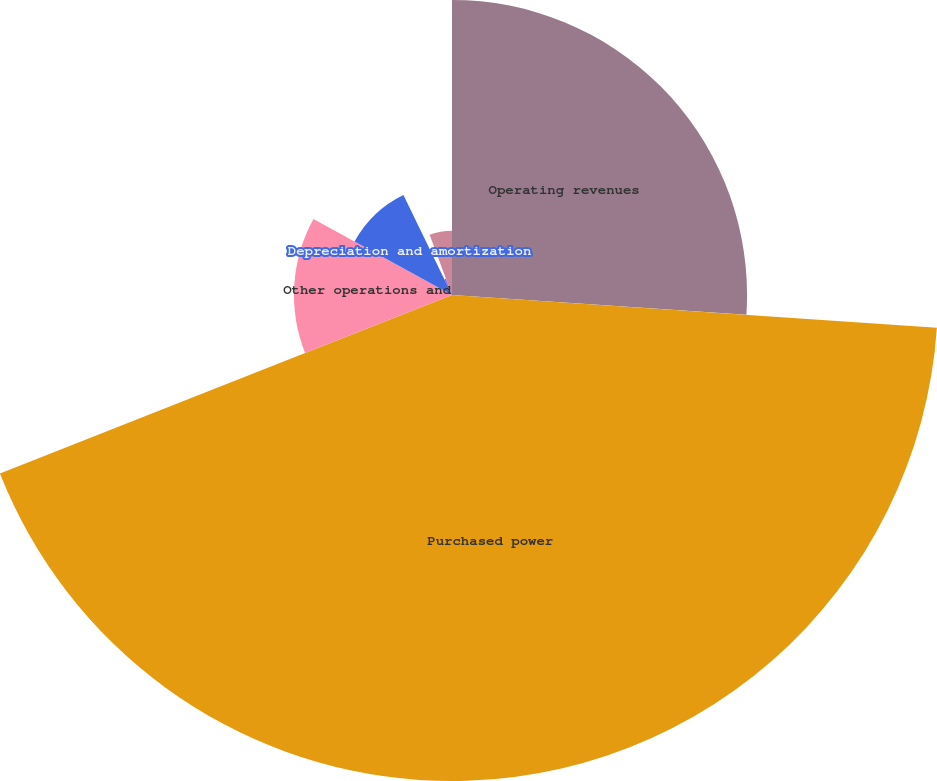Convert chart. <chart><loc_0><loc_0><loc_500><loc_500><pie_chart><fcel>Operating revenues<fcel>Purchased power<fcel>Other operations and<fcel>Depreciation and amortization<fcel>Taxes other than income taxes<fcel>Electric operating income<nl><fcel>26.07%<fcel>42.94%<fcel>13.96%<fcel>9.82%<fcel>1.53%<fcel>5.67%<nl></chart> 